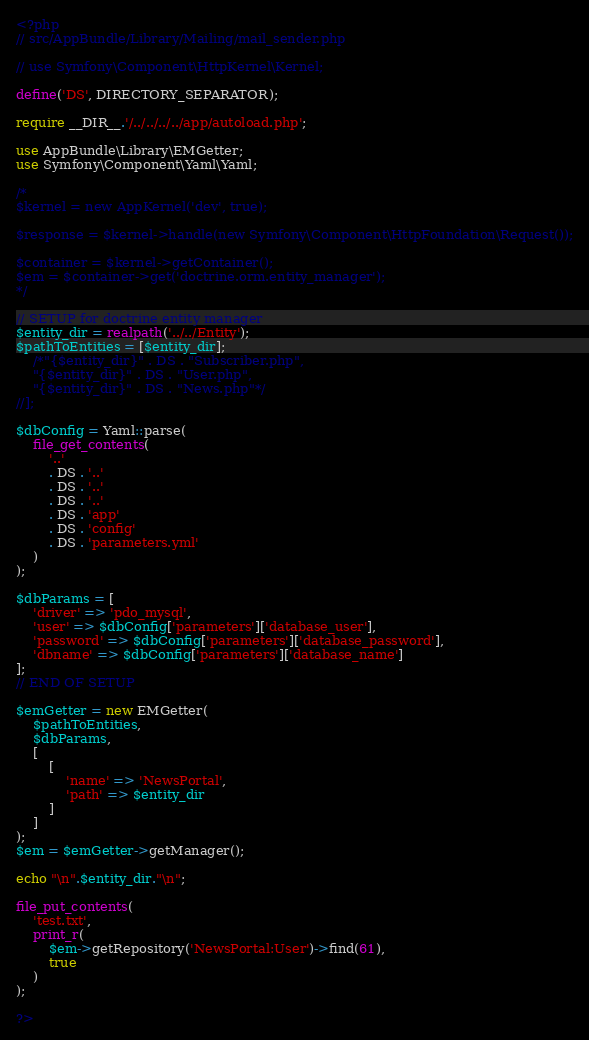<code> <loc_0><loc_0><loc_500><loc_500><_PHP_><?php
// src/AppBundle/Library/Mailing/mail_sender.php

// use Symfony\Component\HttpKernel\Kernel;

define('DS', DIRECTORY_SEPARATOR);

require __DIR__.'/../../../../app/autoload.php';

use AppBundle\Library\EMGetter;
use Symfony\Component\Yaml\Yaml;

/*
$kernel = new AppKernel('dev', true);

$response = $kernel->handle(new Symfony\Component\HttpFoundation\Request());

$container = $kernel->getContainer();
$em = $container->get('doctrine.orm.entity_manager');
*/

// SETUP for doctrine entity manager
$entity_dir = realpath('../../Entity');
$pathToEntities = [$entity_dir];
	/*"{$entity_dir}" . DS . "Subscriber.php",
	"{$entity_dir}" . DS . "User.php",
	"{$entity_dir}" . DS . "News.php"*/
//];

$dbConfig = Yaml::parse(
	file_get_contents(
		'..'
		. DS . '..'
		. DS . '..'
		. DS . '..'
		. DS . 'app'
		. DS . 'config'
		. DS . 'parameters.yml'
	)
);

$dbParams = [
	'driver' => 'pdo_mysql',
	'user' => $dbConfig['parameters']['database_user'],
	'password' => $dbConfig['parameters']['database_password'],
	'dbname' => $dbConfig['parameters']['database_name']
];
// END OF SETUP

$emGetter = new EMGetter(
	$pathToEntities,
	$dbParams,
	[
		[
			'name' => 'NewsPortal',
			'path' => $entity_dir
		]
	]
);
$em = $emGetter->getManager();

echo "\n".$entity_dir."\n";

file_put_contents(
	'test.txt',
	print_r(
		$em->getRepository('NewsPortal:User')->find(61),
		true
	)
);

?></code> 